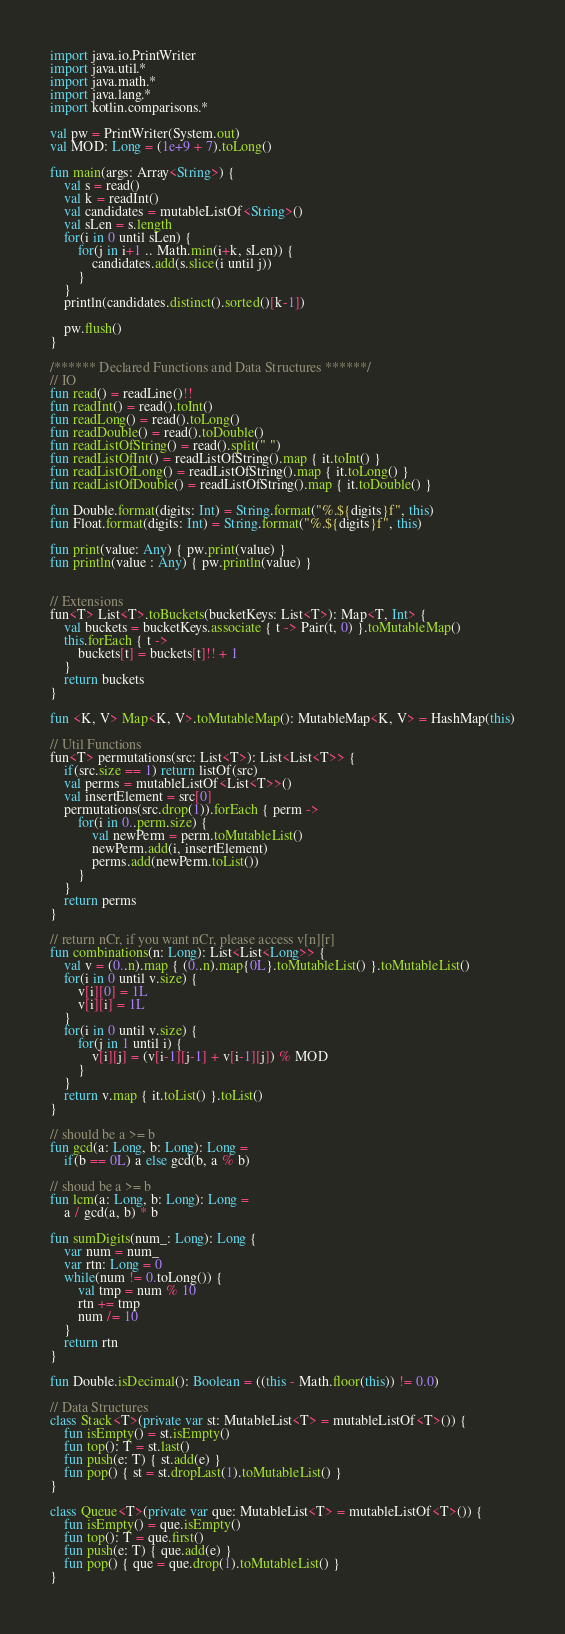<code> <loc_0><loc_0><loc_500><loc_500><_Kotlin_>import java.io.PrintWriter
import java.util.*
import java.math.*
import java.lang.*
import kotlin.comparisons.*

val pw = PrintWriter(System.out)
val MOD: Long = (1e+9 + 7).toLong()

fun main(args: Array<String>) {
    val s = read()
    val k = readInt()
    val candidates = mutableListOf<String>()
    val sLen = s.length
    for(i in 0 until sLen) {
        for(j in i+1 .. Math.min(i+k, sLen)) {
            candidates.add(s.slice(i until j))
        }
    }
    println(candidates.distinct().sorted()[k-1])

    pw.flush()
}

/****** Declared Functions and Data Structures ******/
// IO
fun read() = readLine()!!
fun readInt() = read().toInt()
fun readLong() = read().toLong()
fun readDouble() = read().toDouble()
fun readListOfString() = read().split(" ")
fun readListOfInt() = readListOfString().map { it.toInt() }
fun readListOfLong() = readListOfString().map { it.toLong() }
fun readListOfDouble() = readListOfString().map { it.toDouble() }

fun Double.format(digits: Int) = String.format("%.${digits}f", this)
fun Float.format(digits: Int) = String.format("%.${digits}f", this)

fun print(value: Any) { pw.print(value) }
fun println(value : Any) { pw.println(value) }


// Extensions
fun<T> List<T>.toBuckets(bucketKeys: List<T>): Map<T, Int> {
    val buckets = bucketKeys.associate { t -> Pair(t, 0) }.toMutableMap()
    this.forEach { t ->
        buckets[t] = buckets[t]!! + 1
    }
    return buckets
}

fun <K, V> Map<K, V>.toMutableMap(): MutableMap<K, V> = HashMap(this)

// Util Functions
fun<T> permutations(src: List<T>): List<List<T>> {
    if(src.size == 1) return listOf(src)
    val perms = mutableListOf<List<T>>()
    val insertElement = src[0]
    permutations(src.drop(1)).forEach { perm ->
        for(i in 0..perm.size) {
            val newPerm = perm.toMutableList()
            newPerm.add(i, insertElement)
            perms.add(newPerm.toList())
        }
    }
    return perms
}

// return nCr, if you want nCr, please access v[n][r]
fun combinations(n: Long): List<List<Long>> {
    val v = (0..n).map { (0..n).map{0L}.toMutableList() }.toMutableList()
    for(i in 0 until v.size) {
        v[i][0] = 1L
        v[i][i] = 1L
    }
    for(i in 0 until v.size) {
        for(j in 1 until i) {
            v[i][j] = (v[i-1][j-1] + v[i-1][j]) % MOD
        }
    }
    return v.map { it.toList() }.toList()
}

// should be a >= b
fun gcd(a: Long, b: Long): Long = 
    if(b == 0L) a else gcd(b, a % b)

// shoud be a >= b
fun lcm(a: Long, b: Long): Long = 
    a / gcd(a, b) * b

fun sumDigits(num_: Long): Long {
    var num = num_
    var rtn: Long = 0
    while(num != 0.toLong()) {
        val tmp = num % 10
        rtn += tmp
        num /= 10
    }
    return rtn
}

fun Double.isDecimal(): Boolean = ((this - Math.floor(this)) != 0.0)

// Data Structures
class Stack<T>(private var st: MutableList<T> = mutableListOf<T>()) {
    fun isEmpty() = st.isEmpty()
    fun top(): T = st.last()
    fun push(e: T) { st.add(e) }
    fun pop() { st = st.dropLast(1).toMutableList() }
}

class Queue<T>(private var que: MutableList<T> = mutableListOf<T>()) {
    fun isEmpty() = que.isEmpty()
    fun top(): T = que.first()
    fun push(e: T) { que.add(e) }
    fun pop() { que = que.drop(1).toMutableList() }
}
</code> 